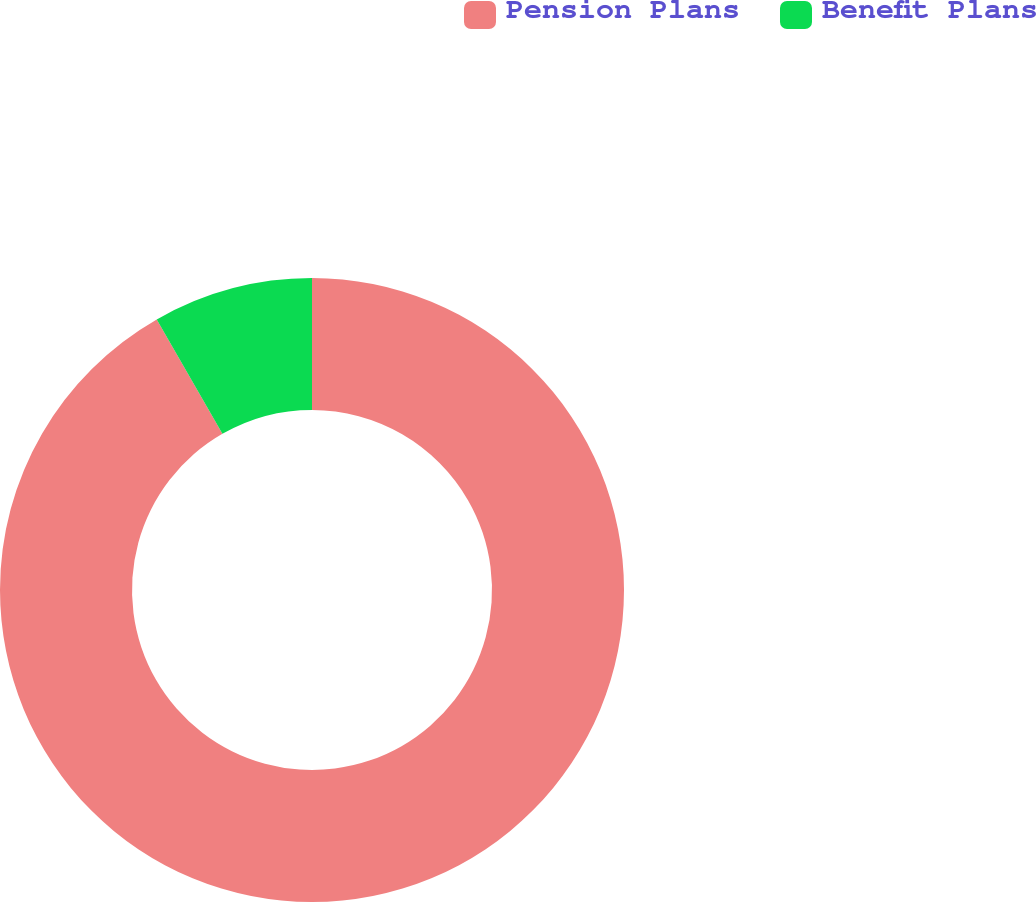<chart> <loc_0><loc_0><loc_500><loc_500><pie_chart><fcel>Pension Plans<fcel>Benefit Plans<nl><fcel>91.71%<fcel>8.29%<nl></chart> 